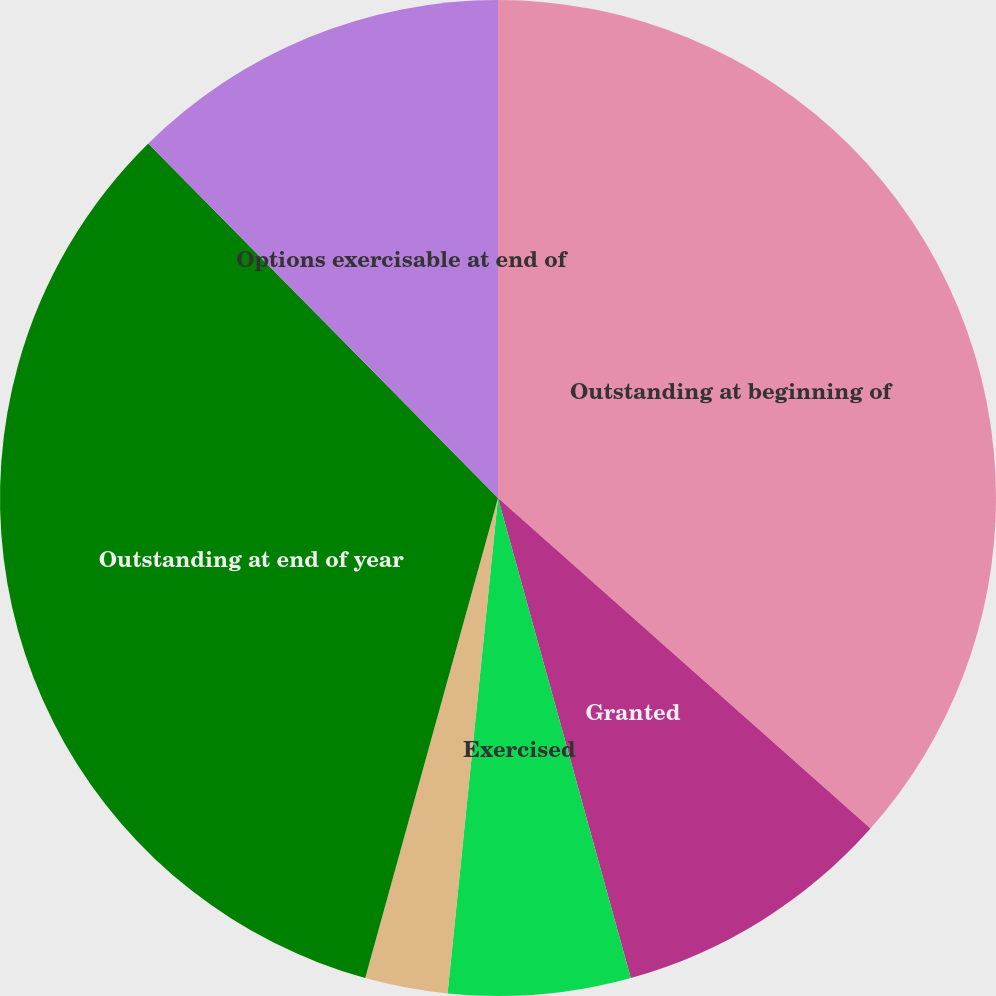<chart> <loc_0><loc_0><loc_500><loc_500><pie_chart><fcel>Outstanding at beginning of<fcel>Granted<fcel>Exercised<fcel>Canceled<fcel>Outstanding at end of year<fcel>Options exercisable at end of<nl><fcel>36.55%<fcel>9.15%<fcel>5.91%<fcel>2.68%<fcel>33.31%<fcel>12.39%<nl></chart> 